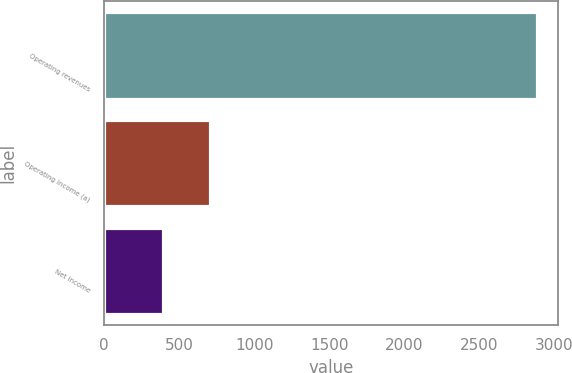Convert chart. <chart><loc_0><loc_0><loc_500><loc_500><bar_chart><fcel>Operating revenues<fcel>Operating income (a)<fcel>Net income<nl><fcel>2884<fcel>705<fcel>389<nl></chart> 